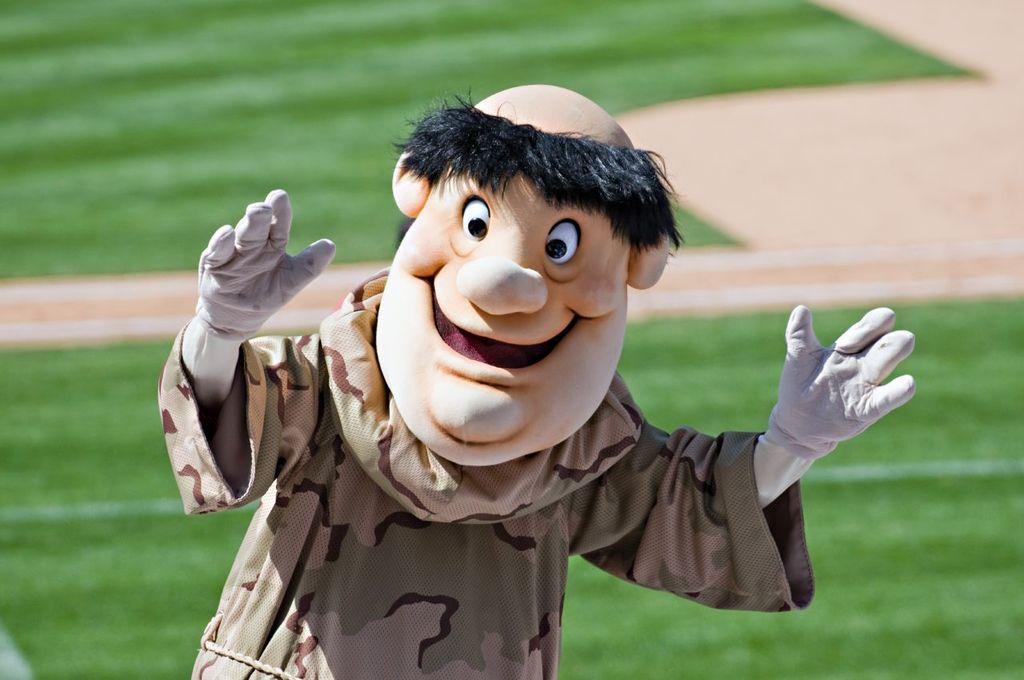Can you describe this image briefly? In this image I can see the person is wearing different color costume. Back I can see the green grass. 